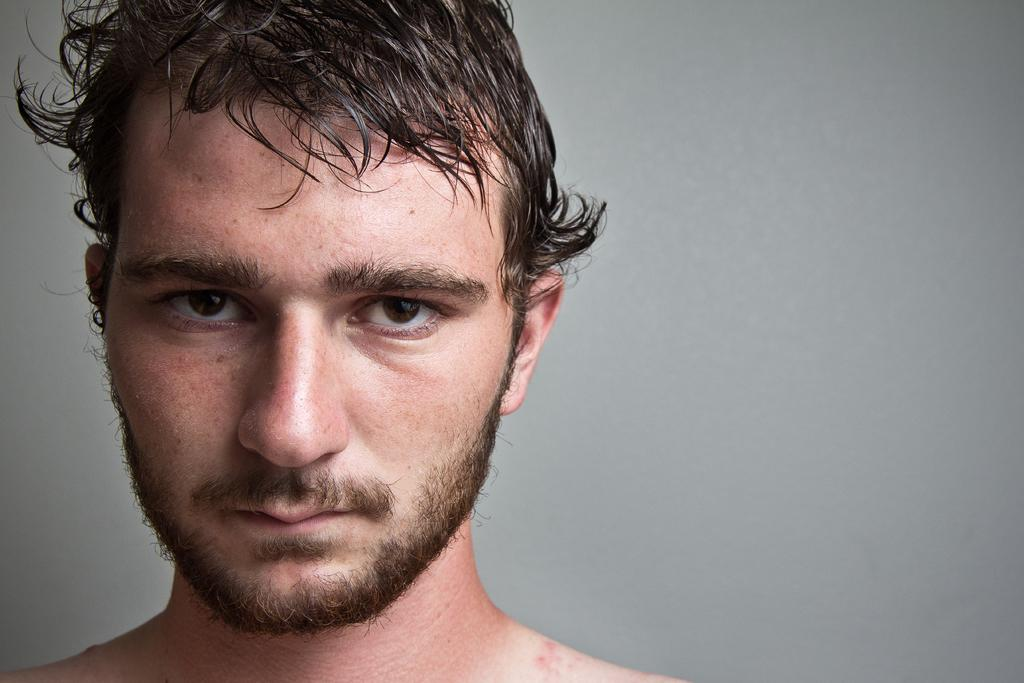What is the main subject of the image? The main subject of the image is the face of a man. What type of health benefits can be gained from the jewel in the image? There is no jewel present in the image, so it is not possible to discuss any health benefits associated with it. 